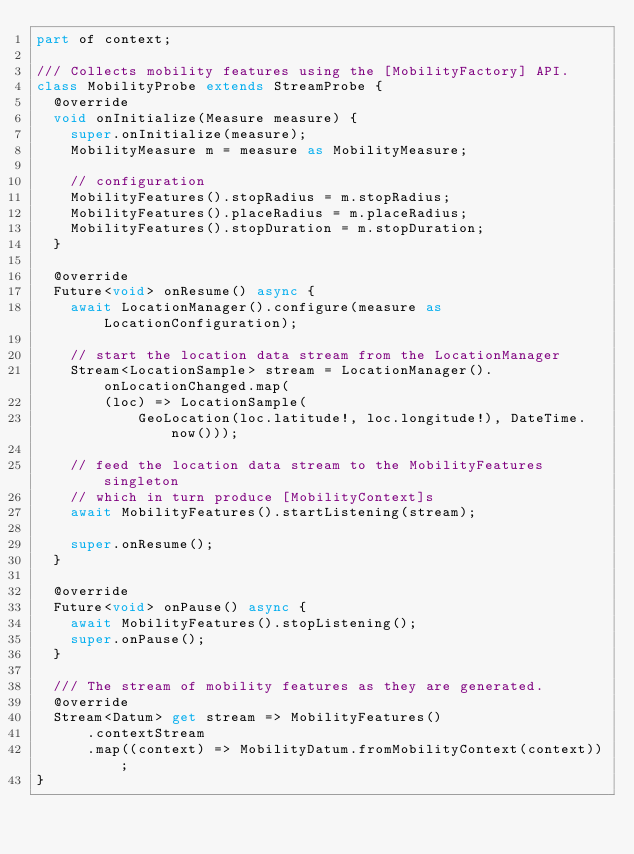Convert code to text. <code><loc_0><loc_0><loc_500><loc_500><_Dart_>part of context;

/// Collects mobility features using the [MobilityFactory] API.
class MobilityProbe extends StreamProbe {
  @override
  void onInitialize(Measure measure) {
    super.onInitialize(measure);
    MobilityMeasure m = measure as MobilityMeasure;

    // configuration
    MobilityFeatures().stopRadius = m.stopRadius;
    MobilityFeatures().placeRadius = m.placeRadius;
    MobilityFeatures().stopDuration = m.stopDuration;
  }

  @override
  Future<void> onResume() async {
    await LocationManager().configure(measure as LocationConfiguration);

    // start the location data stream from the LocationManager
    Stream<LocationSample> stream = LocationManager().onLocationChanged.map(
        (loc) => LocationSample(
            GeoLocation(loc.latitude!, loc.longitude!), DateTime.now()));

    // feed the location data stream to the MobilityFeatures singleton
    // which in turn produce [MobilityContext]s
    await MobilityFeatures().startListening(stream);

    super.onResume();
  }

  @override
  Future<void> onPause() async {
    await MobilityFeatures().stopListening();
    super.onPause();
  }

  /// The stream of mobility features as they are generated.
  @override
  Stream<Datum> get stream => MobilityFeatures()
      .contextStream
      .map((context) => MobilityDatum.fromMobilityContext(context));
}
</code> 